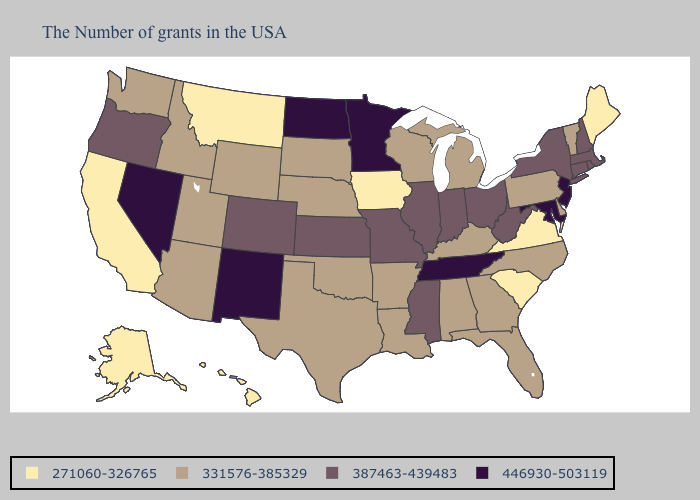Name the states that have a value in the range 271060-326765?
Answer briefly. Maine, Virginia, South Carolina, Iowa, Montana, California, Alaska, Hawaii. Does Maine have the lowest value in the Northeast?
Write a very short answer. Yes. Among the states that border Michigan , does Wisconsin have the lowest value?
Give a very brief answer. Yes. Among the states that border Mississippi , does Arkansas have the lowest value?
Give a very brief answer. Yes. What is the value of Tennessee?
Give a very brief answer. 446930-503119. Name the states that have a value in the range 446930-503119?
Concise answer only. New Jersey, Maryland, Tennessee, Minnesota, North Dakota, New Mexico, Nevada. Name the states that have a value in the range 271060-326765?
Be succinct. Maine, Virginia, South Carolina, Iowa, Montana, California, Alaska, Hawaii. What is the highest value in the USA?
Write a very short answer. 446930-503119. Which states have the highest value in the USA?
Keep it brief. New Jersey, Maryland, Tennessee, Minnesota, North Dakota, New Mexico, Nevada. Does Massachusetts have the lowest value in the Northeast?
Short answer required. No. Name the states that have a value in the range 331576-385329?
Be succinct. Vermont, Delaware, Pennsylvania, North Carolina, Florida, Georgia, Michigan, Kentucky, Alabama, Wisconsin, Louisiana, Arkansas, Nebraska, Oklahoma, Texas, South Dakota, Wyoming, Utah, Arizona, Idaho, Washington. Name the states that have a value in the range 331576-385329?
Quick response, please. Vermont, Delaware, Pennsylvania, North Carolina, Florida, Georgia, Michigan, Kentucky, Alabama, Wisconsin, Louisiana, Arkansas, Nebraska, Oklahoma, Texas, South Dakota, Wyoming, Utah, Arizona, Idaho, Washington. What is the highest value in states that border Arizona?
Give a very brief answer. 446930-503119. Does Florida have the same value as North Carolina?
Quick response, please. Yes. Among the states that border Kentucky , which have the highest value?
Give a very brief answer. Tennessee. 